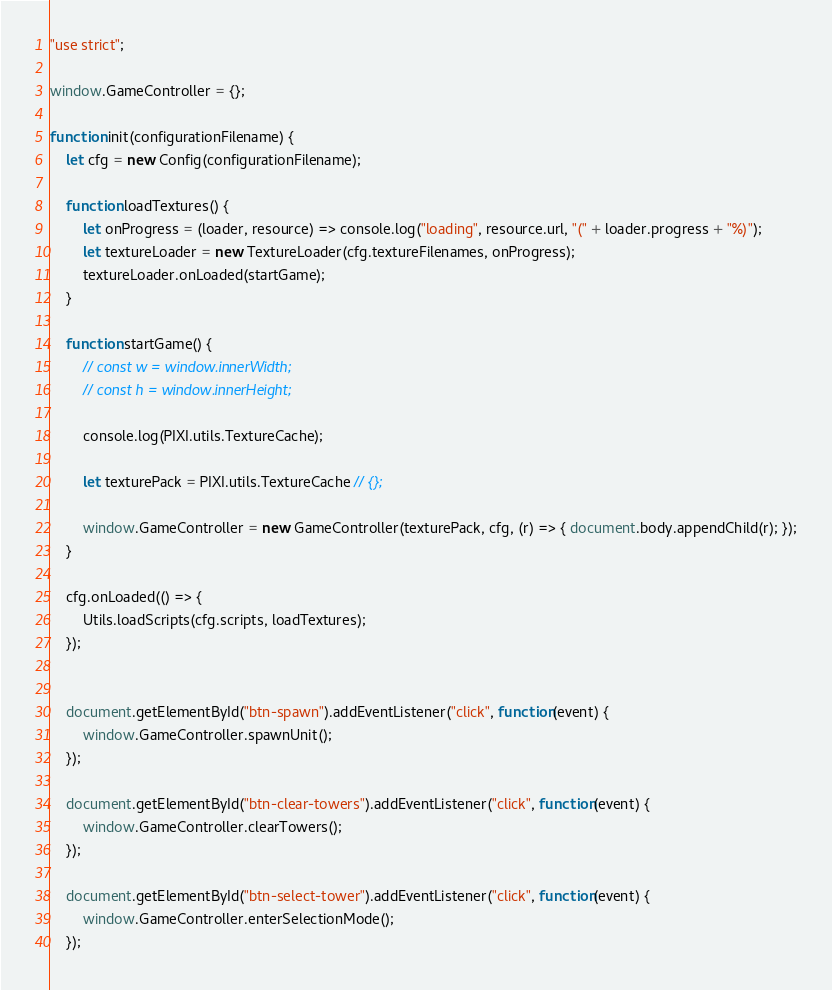Convert code to text. <code><loc_0><loc_0><loc_500><loc_500><_JavaScript_>"use strict";

window.GameController = {};

function init(configurationFilename) {
    let cfg = new Config(configurationFilename);

    function loadTextures() {
        let onProgress = (loader, resource) => console.log("loading", resource.url, "(" + loader.progress + "%)");
        let textureLoader = new TextureLoader(cfg.textureFilenames, onProgress);
        textureLoader.onLoaded(startGame);
    }

    function startGame() {
        // const w = window.innerWidth;
        // const h = window.innerHeight;

        console.log(PIXI.utils.TextureCache);

        let texturePack = PIXI.utils.TextureCache // {};

        window.GameController = new GameController(texturePack, cfg, (r) => { document.body.appendChild(r); });
    }

    cfg.onLoaded(() => {
        Utils.loadScripts(cfg.scripts, loadTextures);
    });


    document.getElementById("btn-spawn").addEventListener("click", function(event) {
        window.GameController.spawnUnit();
    });

    document.getElementById("btn-clear-towers").addEventListener("click", function(event) {
        window.GameController.clearTowers();
    });

    document.getElementById("btn-select-tower").addEventListener("click", function(event) {
        window.GameController.enterSelectionMode();
    });
</code> 